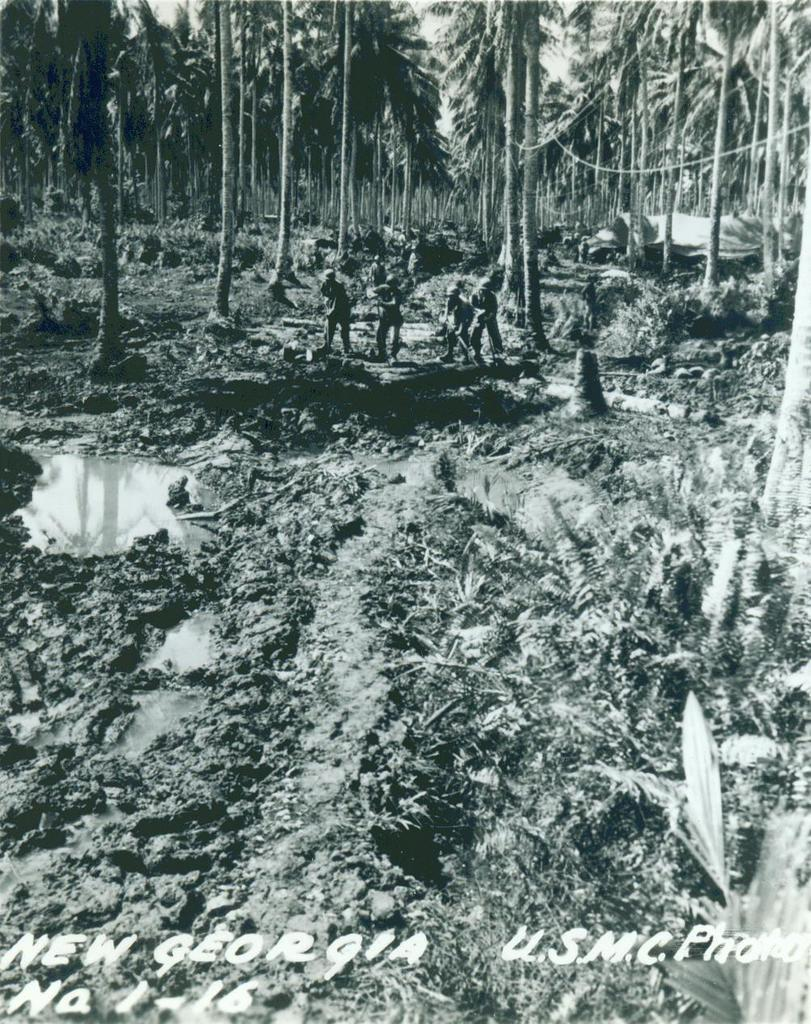What type of living organisms can be seen in the image? Plants and trees are visible in the image. Are there any human subjects in the image? Yes, there are people standing in the image. What is the condition of the sky in the image? The sky is clear in the image. What type of meat can be seen hanging from the trees in the image? There is no meat present in the image; it features plants, trees, and people. Does the existence of the plants and trees in the image prove the existence of a higher power? The presence of plants and trees in the image does not prove the existence of a higher power, as the image only provides visual information about the scene. 